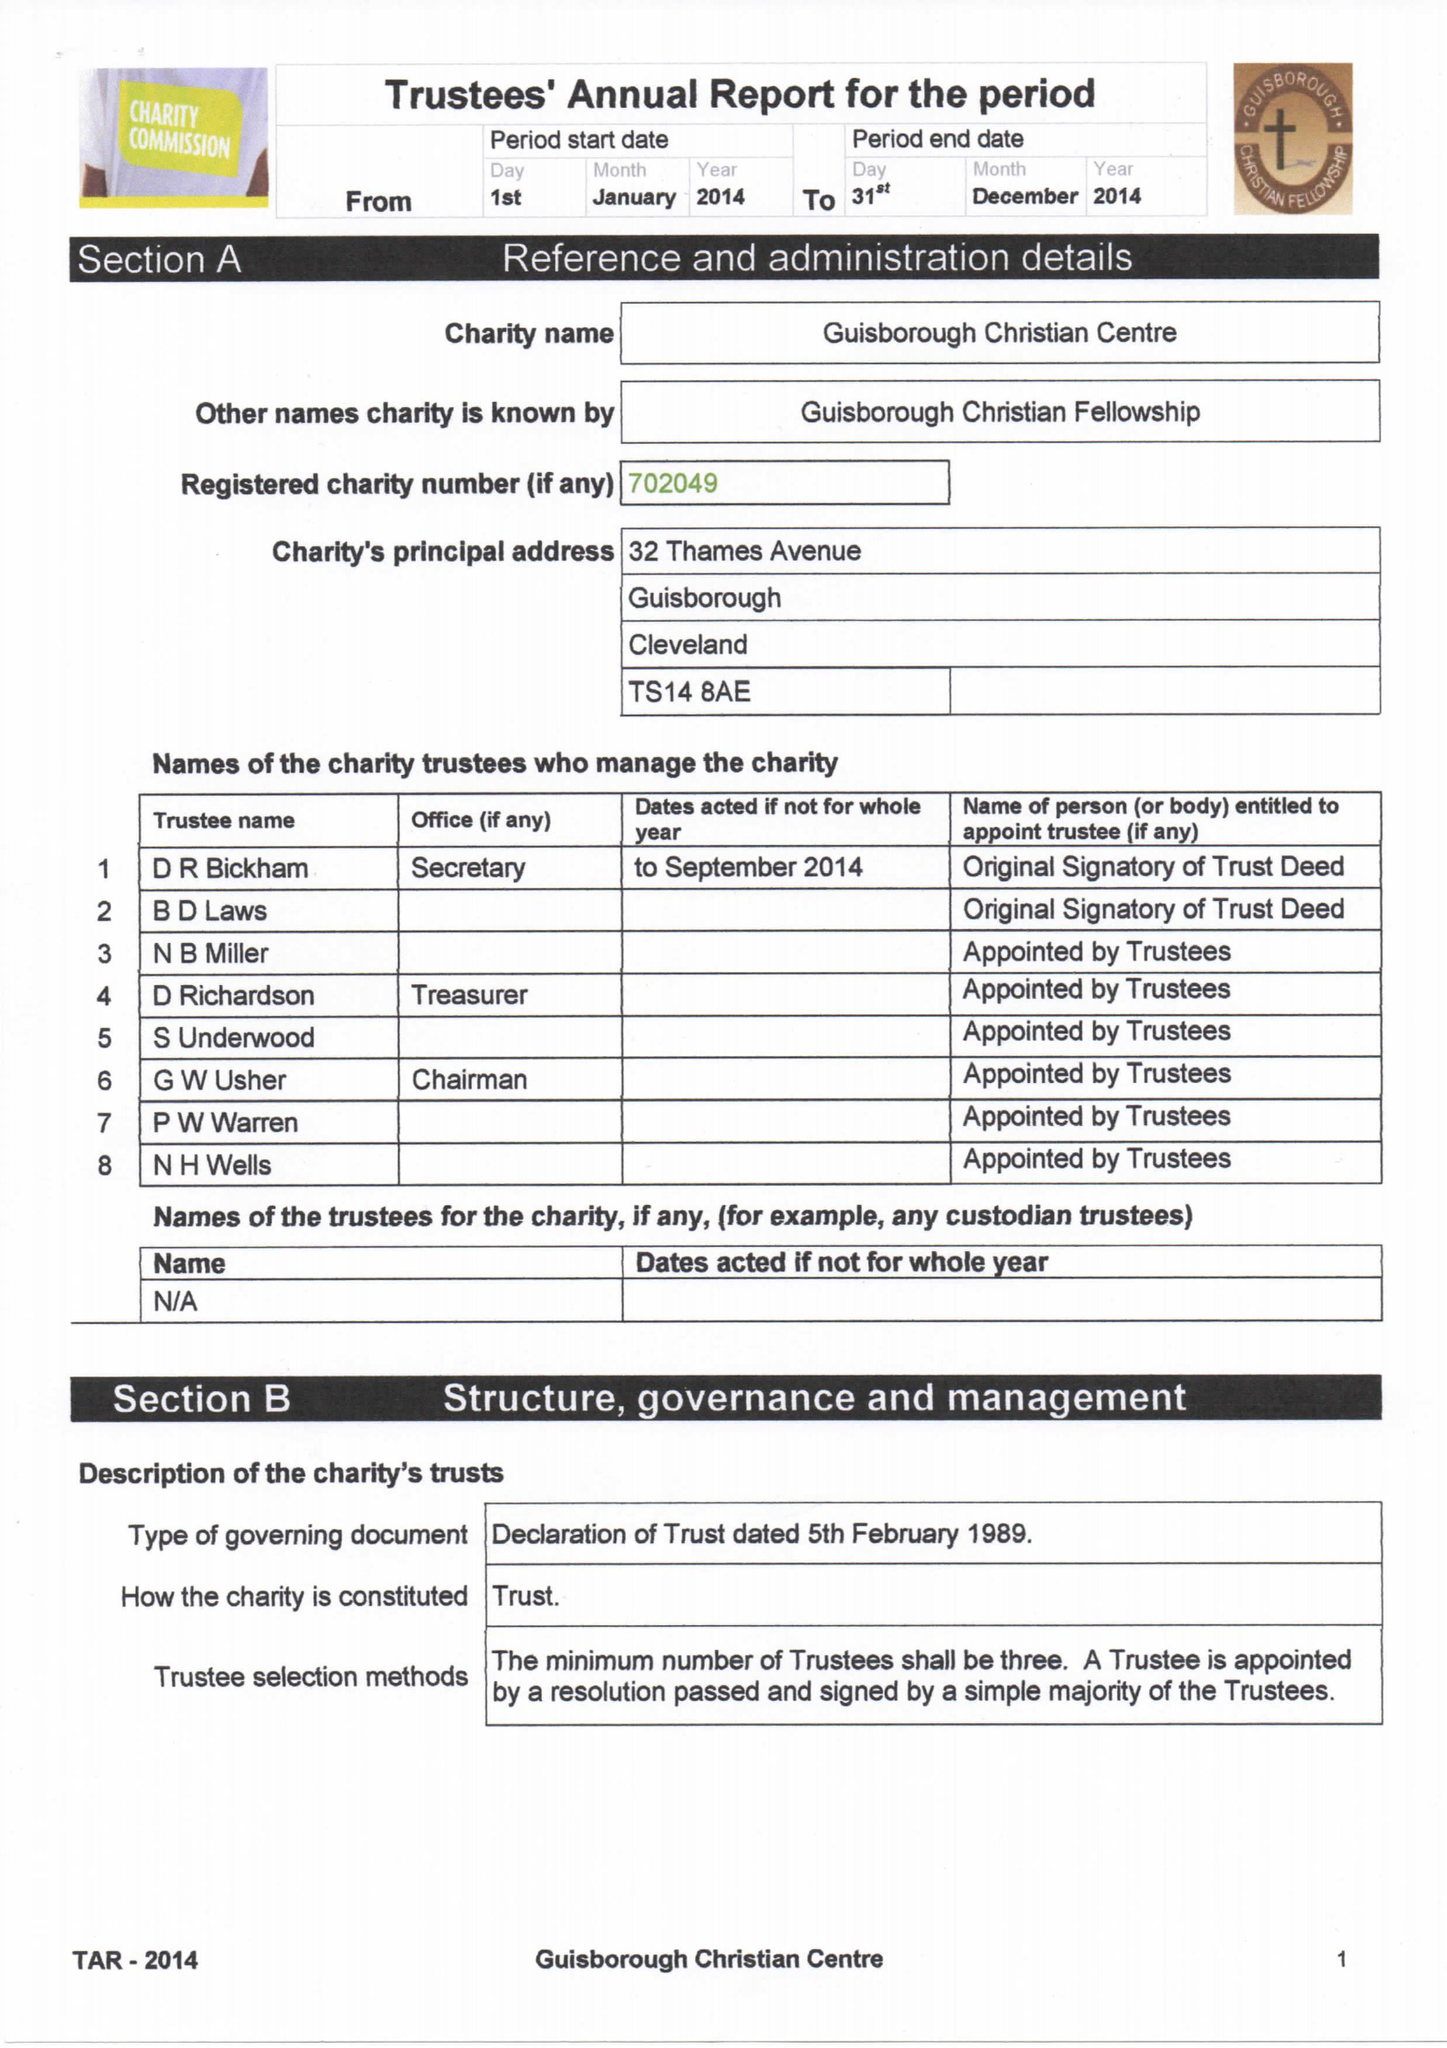What is the value for the report_date?
Answer the question using a single word or phrase. 2014-12-31 